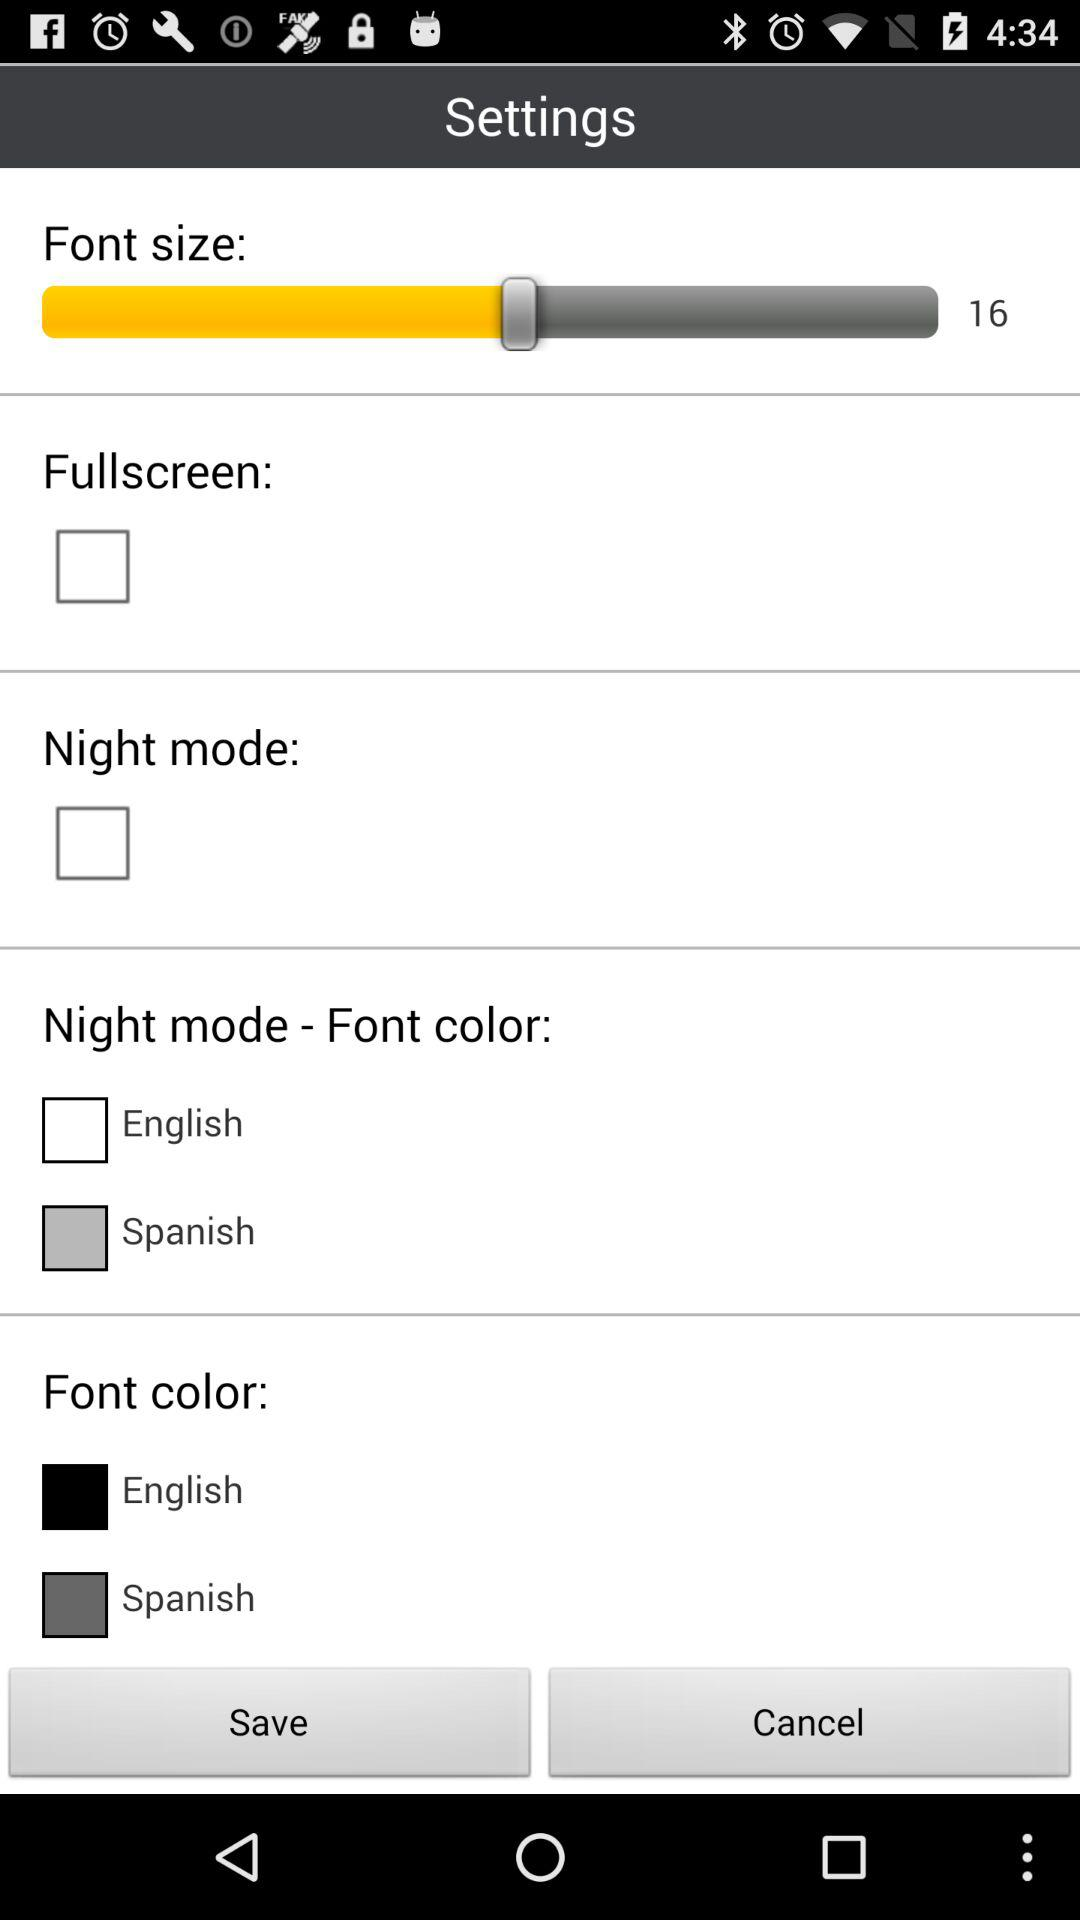How many checkboxes are there that are not related to language?
Answer the question using a single word or phrase. 2 